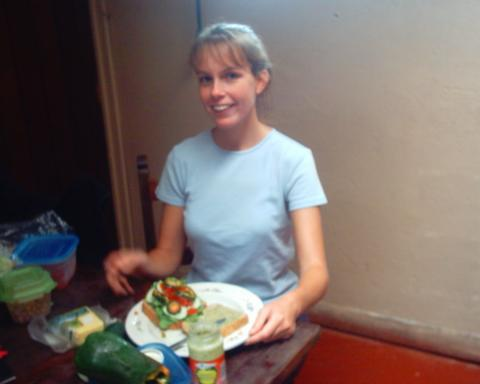Question: where was this photo taken?
Choices:
A. At the border.
B. Along the road.
C. At a restaurant.
D. In the boat.
Answer with the letter. Answer: C Question: why is the woman smiling?
Choices:
A. For the picture.
B. She is happy.
C. It is her wedding.
D. The received a present.
Answer with the letter. Answer: A Question: when was this photo taken?
Choices:
A. At night.
B. Morning.
C. Afternoon.
D. During the day.
Answer with the letter. Answer: D Question: what color is her hair?
Choices:
A. Red.
B. Grey.
C. Brown.
D. Black.
Answer with the letter. Answer: C 